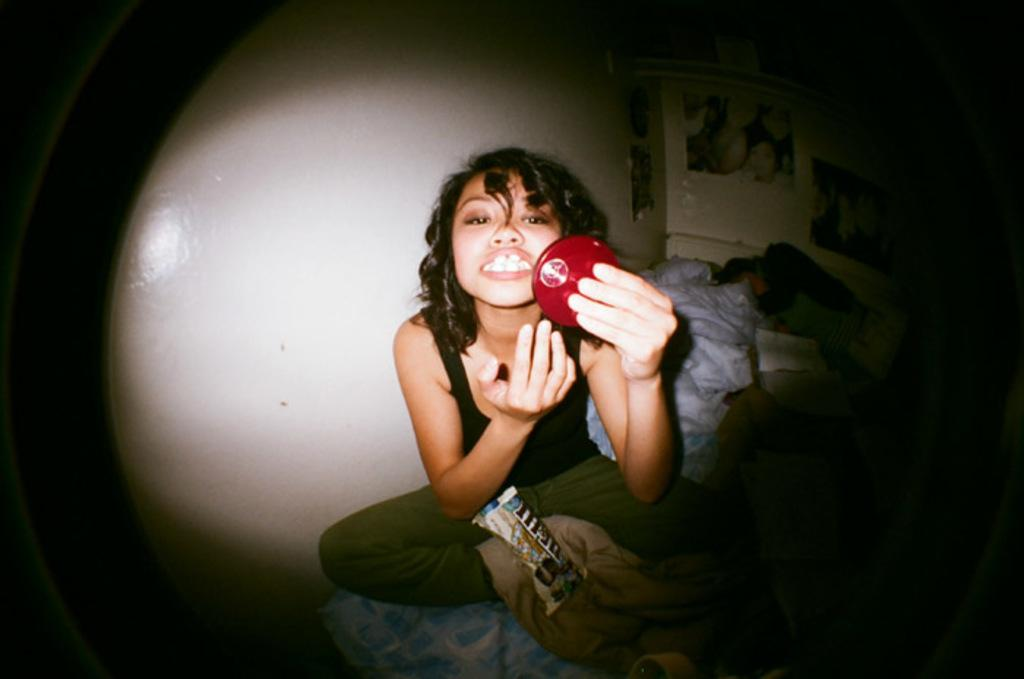Who is present in the image? There is a woman in the image. What is the woman doing in the image? The woman is sitting on a bed and holding a mirror. What can be seen behind the woman? There is a wall behind the woman. What type of bike is leaning against the wall in the image? There is no bike present in the image; it only features a woman sitting on a bed and holding a mirror. 